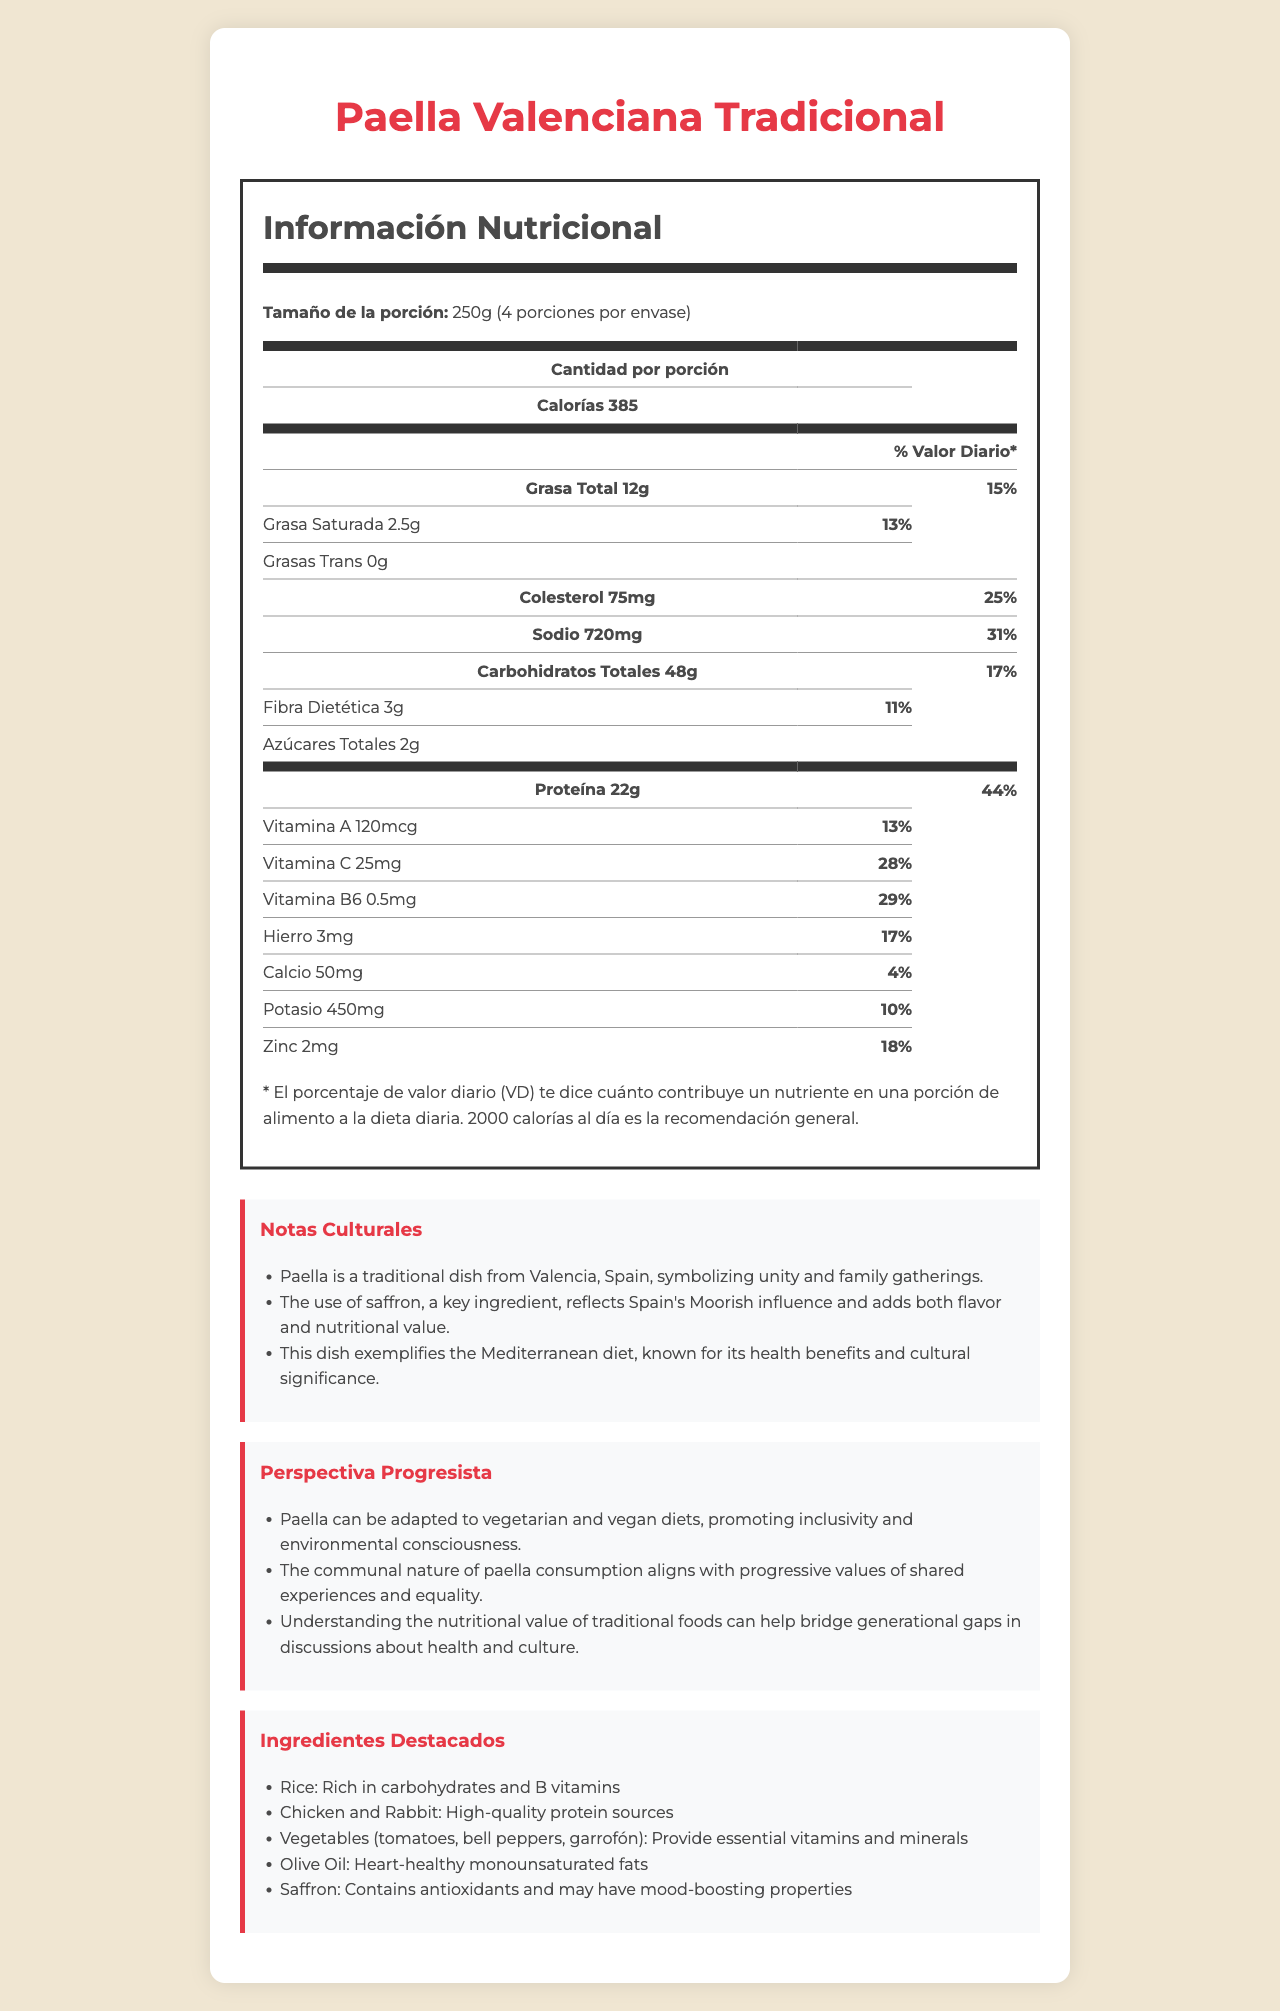what is the serving size for Paella Valenciana Tradicional? The document specifies that the serving size for Paella Valenciana Tradicional is 250g.
Answer: 250g How many servings are there per container of Paella Valenciana Tradicional? The document states that there are 4 servings per container.
Answer: 4 What percentage of daily value does the total fat in one serving contribute? The nutrition label indicates that the total fat in one serving contributes 15% of the daily value.
Answer: 15% List two vitamins mentioned in the nutrition label along with their daily values. The document shows that Vitamin A has a daily value of 13% and Vitamin C has a daily value of 28%.
Answer: Vitamin A 13%, Vitamin C 28% What are the primary protein sources in Paella Valenciana Tradicional according to ingredient highlights? The ingredient highlights section mentions that chicken and rabbit are high-quality protein sources.
Answer: Chicken and Rabbit Which nutrient has the highest daily value percentage per serving? A. Sodium B. Protein C. Iron D. Vitamin B6 The nutrition label shows that protein has a daily value percentage of 44%, which is the highest among the listed options.
Answer: B. Protein Which of these ingredients is noted for containing antioxidants? A. Olive Oil B. Saffron C. Garrofón D. Bell peppers The ingredient highlights section states that saffron contains antioxidants.
Answer: B. Saffron Does Paella Valenciana Tradicional contain any trans fat? The nutrition label indicates that the amount of trans fat is 0g, meaning it does not contain any trans fat.
Answer: No Can the cholesterol content in Paella Valenciana Tradicional affect a low-cholesterol diet? The document shows that one serving has 75 mg of cholesterol, which is 25% of the daily value, making it significant for a low-cholesterol diet.
Answer: Yes Summarize the cultural significance of Paella Valenciana Tradicional. The document's cultural notes section describes the cultural importance of paella, highlighting its role in family gatherings, historical influences, and health benefits.
Answer: Paella is a traditional dish from Valencia, Spain, symbolizing unity and family gatherings. The use of saffron reflects Spain's Moorish influence and adds flavor and nutritional value. This dish exemplifies the Mediterranean diet, known for its health benefits and cultural significance. What effect does saffron have on mood according to the document? The document does not provide specific information on the effect of saffron on mood.
Answer: Cannot be determined What are the total sugars per serving in Paella Valenciana Tradicional? The nutrition label specifies that there are 2g of total sugars per serving.
Answer: 2g What is the significance of understanding the nutritional value of traditional foods from a progressive perspective? The progressive perspective section explains that understanding the nutritional value of traditional foods can facilitate discussions between generations about health and culture.
Answer: It can help bridge generational gaps in discussions about health and culture. 